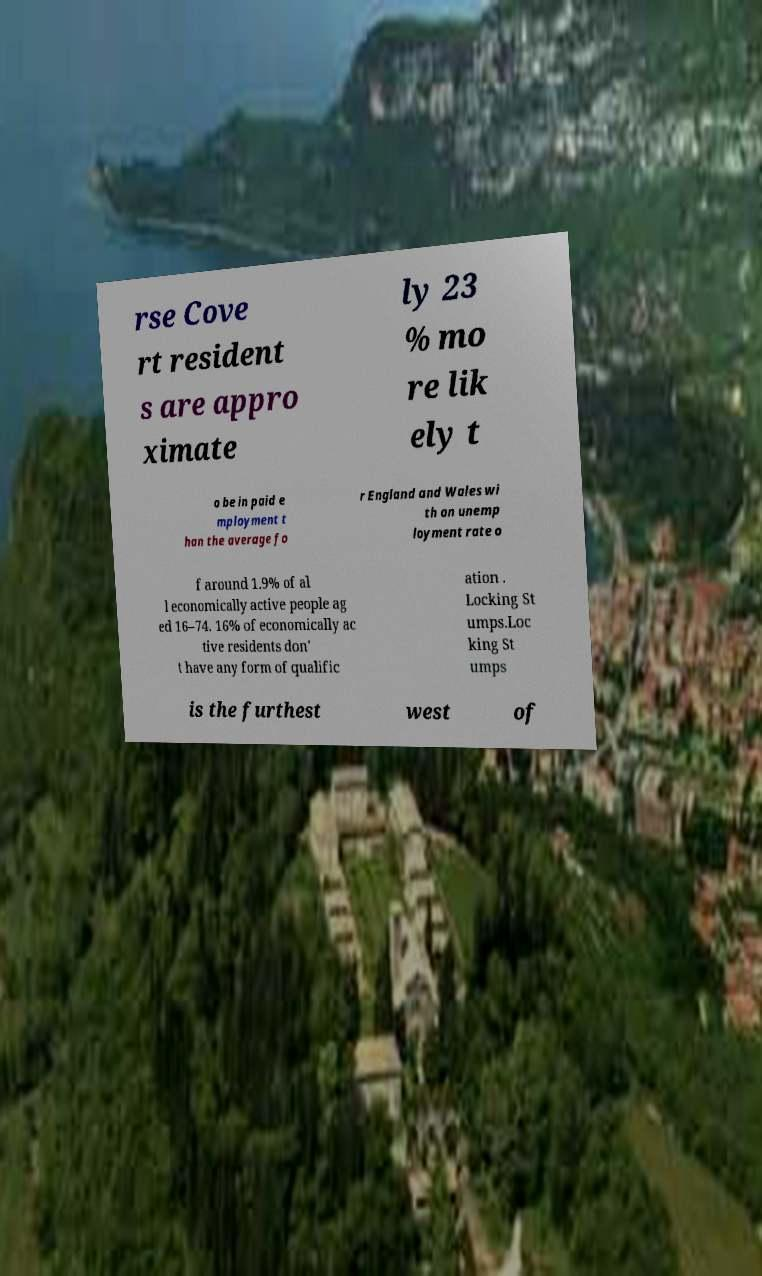Could you extract and type out the text from this image? rse Cove rt resident s are appro ximate ly 23 % mo re lik ely t o be in paid e mployment t han the average fo r England and Wales wi th an unemp loyment rate o f around 1.9% of al l economically active people ag ed 16–74. 16% of economically ac tive residents don' t have any form of qualific ation . Locking St umps.Loc king St umps is the furthest west of 